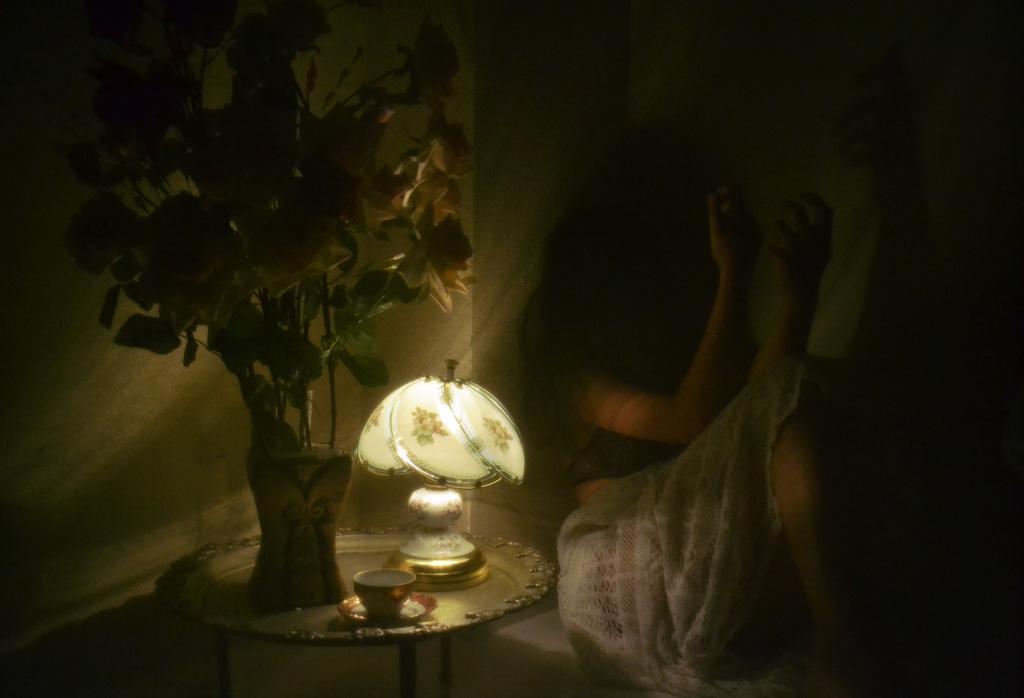How would you summarize this image in a sentence or two? In this image, I can see a person sitting. On the left side of the image, I can see a flower vase with flowers, lamp, cup and saucer on the table. In the background, there is the wall. 